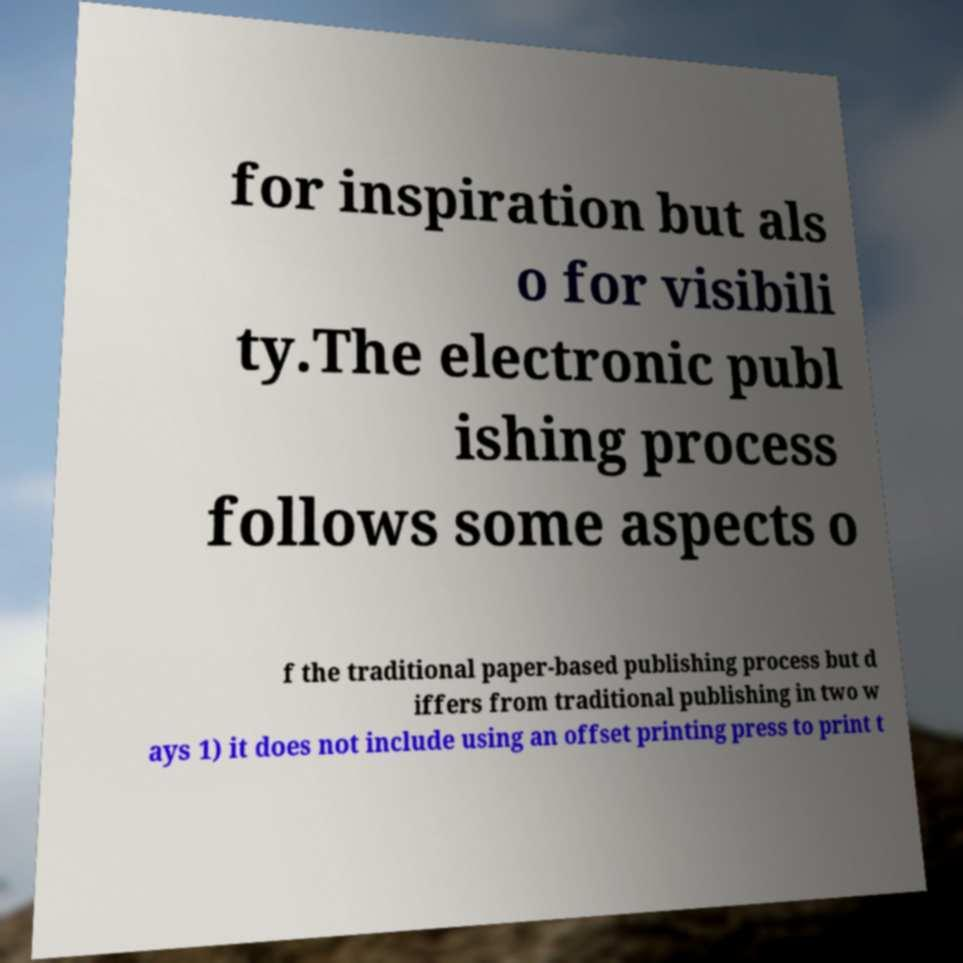Please read and relay the text visible in this image. What does it say? for inspiration but als o for visibili ty.The electronic publ ishing process follows some aspects o f the traditional paper-based publishing process but d iffers from traditional publishing in two w ays 1) it does not include using an offset printing press to print t 